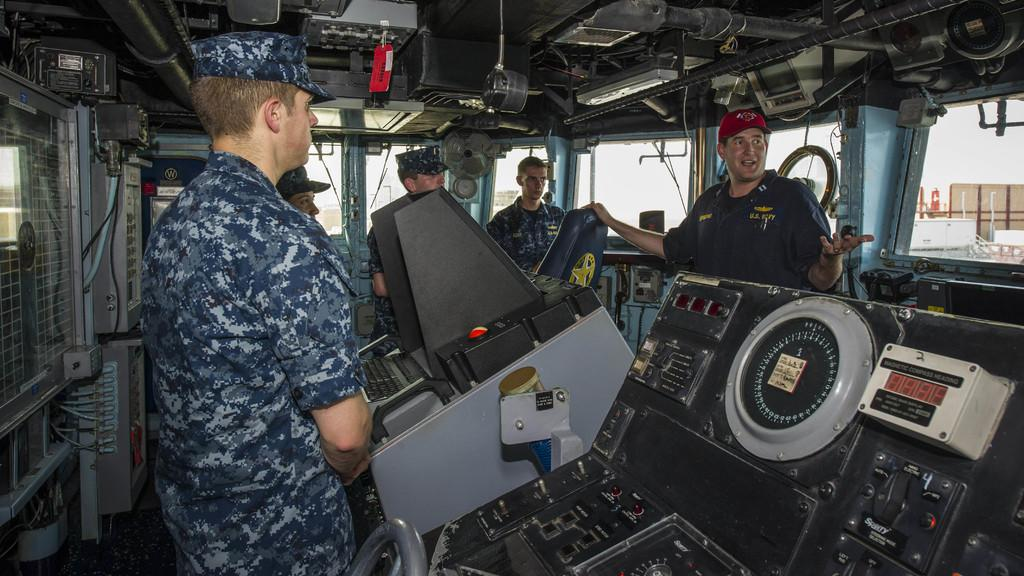What can be observed about the people in the image? There are people standing in the image, and they are wearing uniforms and caps. What might be the purpose of the uniforms and caps? The uniforms and caps suggest that the people are part of a team or organization. What can be seen in the background of the image? There are machines and equipment, as well as rods and other objects in the background of the image. What type of map is being used by the people in the image? There is no map present in the image; the people are wearing uniforms and caps, and there are machines, equipment, rods, and other objects in the background. 